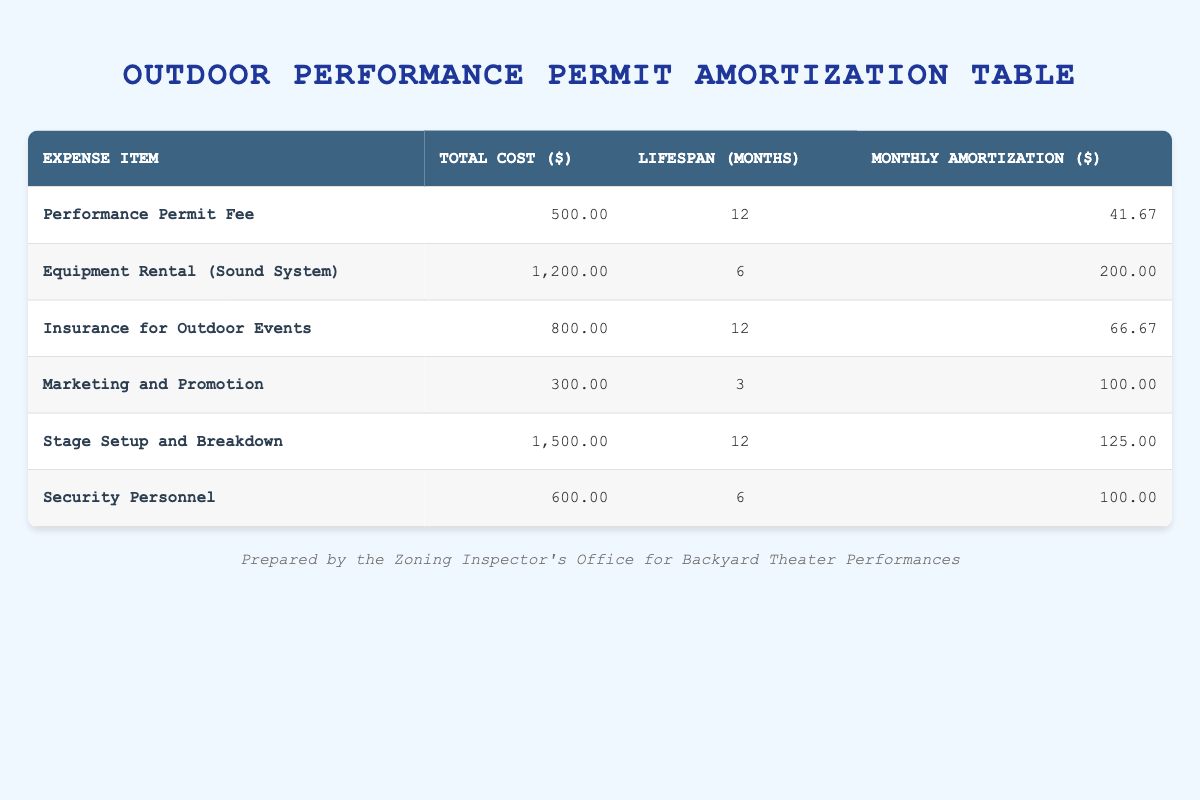What is the total cost for the Performance Permit Fee? The table indicates the total cost for the Performance Permit Fee is listed in the column under Total Cost, which shows 500.00 dollars.
Answer: 500.00 How much is the monthly amortization for the Insurance for Outdoor Events? The table states that the monthly amortization for the Insurance for Outdoor Events is directly noted in the Monthly Amortization column as 66.67 dollars.
Answer: 66.67 Which expense items have a lifespan of 6 months? By examining the Lifespan column, the items Equipment Rental (Sound System) and Security Personnel are both listed with a lifespan of 6 months.
Answer: Equipment Rental (Sound System), Security Personnel What is the average monthly amortization across all expense items? To find the average, first sum the monthly amortizations: 41.67 + 200.00 + 66.67 + 100.00 + 125.00 + 100.00 = 633.34. Then divide by the number of items (6): 633.34 / 6 = 105.56.
Answer: 105.56 Is the total cost of Marketing and Promotion greater than the total cost of Security Personnel? The total cost for Marketing and Promotion is 300.00, while the total cost for Security Personnel is 600.00. Since 300.00 is less than 600.00, the answer is no.
Answer: No What is the total monthly amortization for all expense items combined? By summing the monthly amortizations: 41.67 + 200.00 + 66.67 + 100.00 + 125.00 + 100.00 = 633.34 dollars is the total monthly amortization for all items.
Answer: 633.34 Which has a higher total cost, Stage Setup and Breakdown or Equipment Rental (Sound System)? The total cost for Stage Setup and Breakdown is 1500.00 while the total cost for Equipment Rental (Sound System) is 1200.00. Comparing the two, 1500.00 is greater than 1200.00.
Answer: Stage Setup and Breakdown How many expense items have a monthly amortization of 100.00? The Monthly Amortization column shows two items—Marketing and Promotion and Security Personnel—each have a value of 100.00. Hence, the total number of items is two.
Answer: 2 Is the lifespan of the Performance Permit Fee longer than that of the Marketing and Promotion expense? The Performance Permit Fee has a lifespan of 12 months and Marketing and Promotion has a lifespan of 3 months. Since 12 months is greater than 3 months, the answer is yes.
Answer: Yes 